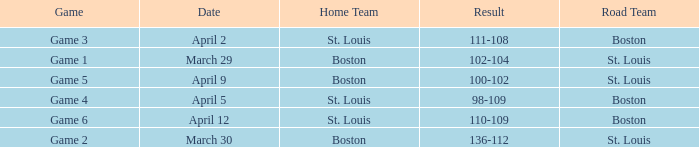What is the Game number on March 30? Game 2. 